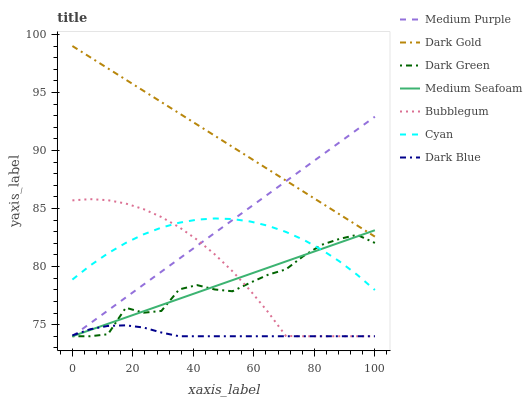Does Dark Blue have the minimum area under the curve?
Answer yes or no. Yes. Does Dark Gold have the maximum area under the curve?
Answer yes or no. Yes. Does Bubblegum have the minimum area under the curve?
Answer yes or no. No. Does Bubblegum have the maximum area under the curve?
Answer yes or no. No. Is Medium Purple the smoothest?
Answer yes or no. Yes. Is Dark Green the roughest?
Answer yes or no. Yes. Is Bubblegum the smoothest?
Answer yes or no. No. Is Bubblegum the roughest?
Answer yes or no. No. Does Bubblegum have the lowest value?
Answer yes or no. Yes. Does Cyan have the lowest value?
Answer yes or no. No. Does Dark Gold have the highest value?
Answer yes or no. Yes. Does Bubblegum have the highest value?
Answer yes or no. No. Is Cyan less than Dark Gold?
Answer yes or no. Yes. Is Cyan greater than Dark Blue?
Answer yes or no. Yes. Does Bubblegum intersect Cyan?
Answer yes or no. Yes. Is Bubblegum less than Cyan?
Answer yes or no. No. Is Bubblegum greater than Cyan?
Answer yes or no. No. Does Cyan intersect Dark Gold?
Answer yes or no. No. 